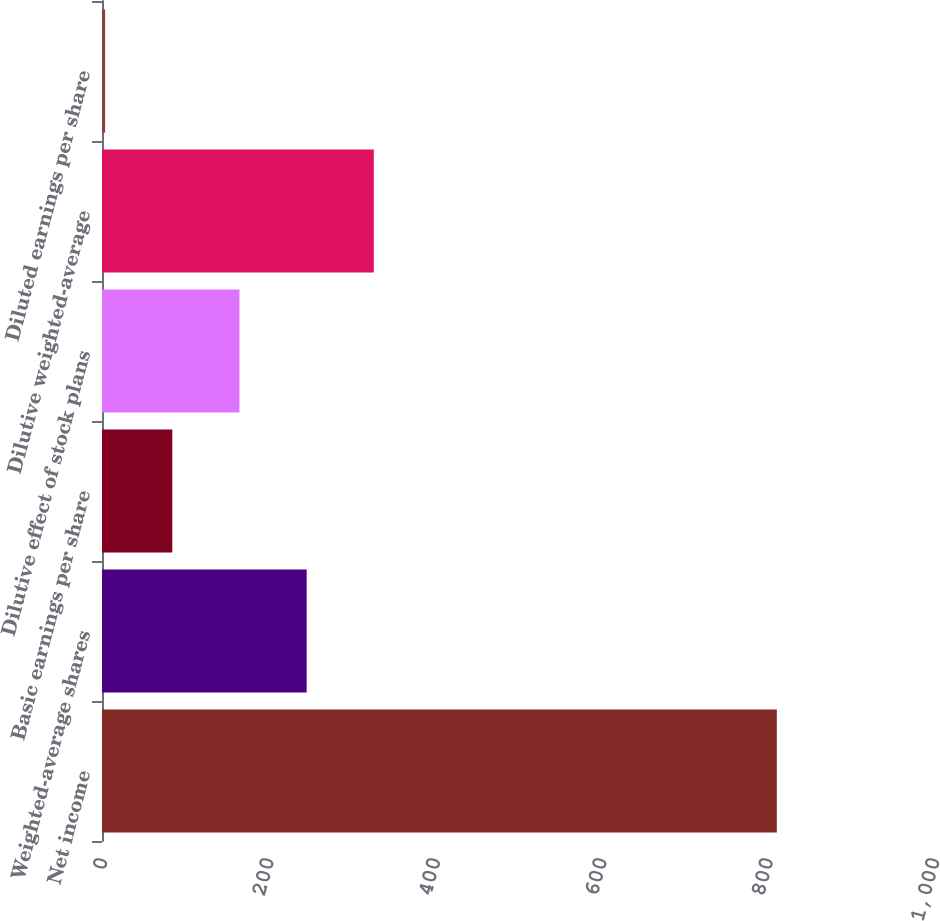Convert chart to OTSL. <chart><loc_0><loc_0><loc_500><loc_500><bar_chart><fcel>Net income<fcel>Weighted-average shares<fcel>Basic earnings per share<fcel>Dilutive effect of stock plans<fcel>Dilutive weighted-average<fcel>Diluted earnings per share<nl><fcel>811.1<fcel>245.96<fcel>84.48<fcel>165.22<fcel>326.7<fcel>3.74<nl></chart> 